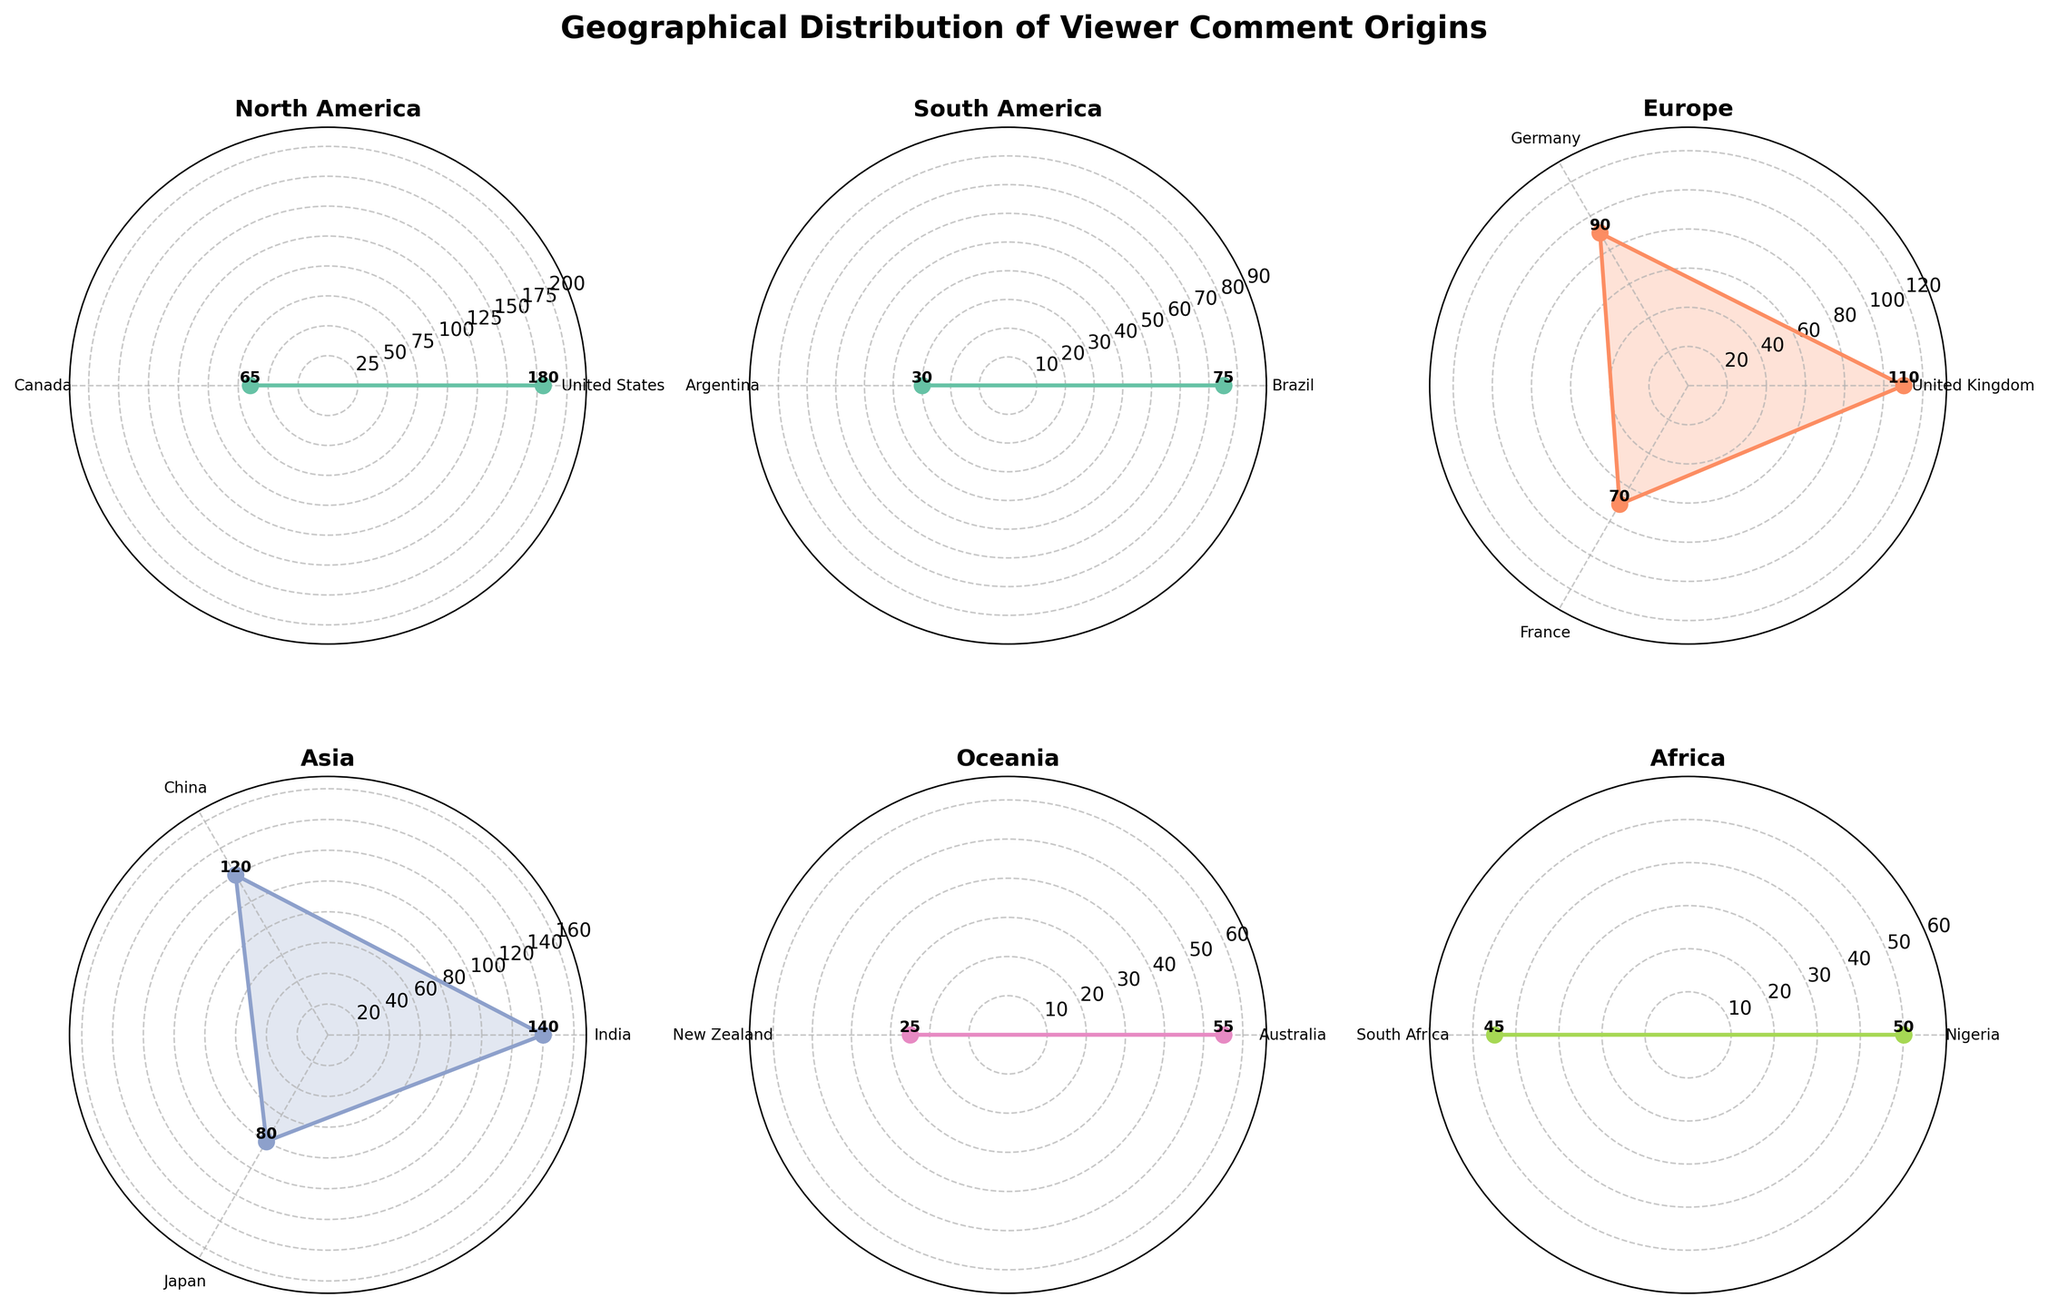what is the region with the highest number of comments in a single country? By examining the plot, we observe that North America has a country (the United States) with the highest number of comments, shown by a data point extending furthest from the center.
Answer: North America How many regions are displayed in the figure? Each subplot's title indicates a region. By counting the titles, we total to six regions.
Answer: Six Which country in Europe has the second highest number of comments? In the Europe subplot, the point representing Germany is slightly smaller than the one for the United Kingdom but larger than others, indicating Germany has the second highest comments.
Answer: Germany What is the sum of comments from Brazil and Argentina? From the South America subplot, Brazil has 75 comments and Argentina has 30. Summing these values yields: 75 + 30 = 105.
Answer: 105 What region has the least number of comments from any single country? By examining the relative sizes of all data points on the subplots, New Zealand in Oceania has the smallest, indicating Oceania.
Answer: Oceania Compare the total number of comments in Africa to Oceania. Which has more? From the subplots, Africa's countries have 50 (Nigeria) + 45 (South Africa) = 95, while Oceania's have 55 (Australia) + 25 (New Zealand) = 80. Thus, Africa has more.
Answer: Africa What is the average number of comments per country in Asia? Summing the comments for Asia: 140 (India) + 120 (China) + 80 (Japan) = 340. Dividing by the number of countries (3) gives: 340 / 3 ≈ 113.33.
Answer: 113.33 Which country from North America and South America, respectively, has the highest number of comments? North America's highest is the United States and South America's highest is Brazil, as seen from the respective subplots.
Answer: United States, Brazil Who has more comments: Canada or France? In their respective subplots, Canada's single point has 65 comments while France's has 70, indicating France has more comments.
Answer: France What is the median number of comments in the European countries? Sorting European comments: 70 (France), 90 (Germany), 110 (United Kingdom), the median value, being the middle one, is 90.
Answer: 90 